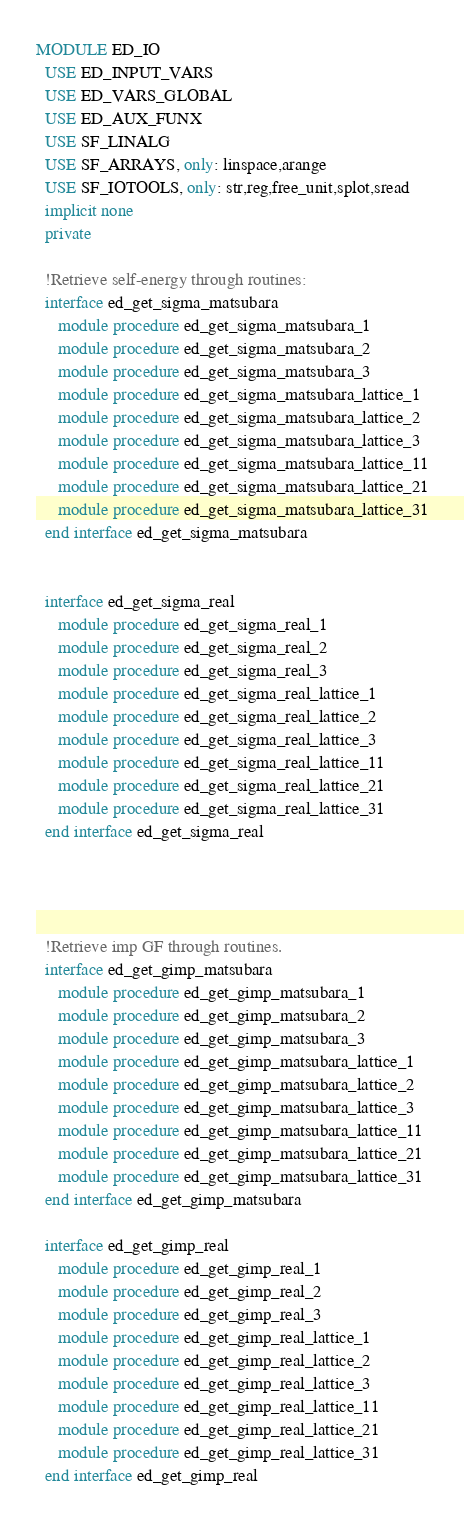<code> <loc_0><loc_0><loc_500><loc_500><_FORTRAN_>MODULE ED_IO
  USE ED_INPUT_VARS
  USE ED_VARS_GLOBAL
  USE ED_AUX_FUNX
  USE SF_LINALG
  USE SF_ARRAYS, only: linspace,arange
  USE SF_IOTOOLS, only: str,reg,free_unit,splot,sread
  implicit none
  private

  !Retrieve self-energy through routines:
  interface ed_get_sigma_matsubara
     module procedure ed_get_sigma_matsubara_1
     module procedure ed_get_sigma_matsubara_2
     module procedure ed_get_sigma_matsubara_3
     module procedure ed_get_sigma_matsubara_lattice_1
     module procedure ed_get_sigma_matsubara_lattice_2
     module procedure ed_get_sigma_matsubara_lattice_3
     module procedure ed_get_sigma_matsubara_lattice_11
     module procedure ed_get_sigma_matsubara_lattice_21
     module procedure ed_get_sigma_matsubara_lattice_31
  end interface ed_get_sigma_matsubara


  interface ed_get_sigma_real
     module procedure ed_get_sigma_real_1
     module procedure ed_get_sigma_real_2
     module procedure ed_get_sigma_real_3
     module procedure ed_get_sigma_real_lattice_1
     module procedure ed_get_sigma_real_lattice_2
     module procedure ed_get_sigma_real_lattice_3
     module procedure ed_get_sigma_real_lattice_11
     module procedure ed_get_sigma_real_lattice_21
     module procedure ed_get_sigma_real_lattice_31
  end interface ed_get_sigma_real




  !Retrieve imp GF through routines.
  interface ed_get_gimp_matsubara
     module procedure ed_get_gimp_matsubara_1
     module procedure ed_get_gimp_matsubara_2
     module procedure ed_get_gimp_matsubara_3
     module procedure ed_get_gimp_matsubara_lattice_1
     module procedure ed_get_gimp_matsubara_lattice_2
     module procedure ed_get_gimp_matsubara_lattice_3
     module procedure ed_get_gimp_matsubara_lattice_11
     module procedure ed_get_gimp_matsubara_lattice_21
     module procedure ed_get_gimp_matsubara_lattice_31
  end interface ed_get_gimp_matsubara

  interface ed_get_gimp_real
     module procedure ed_get_gimp_real_1
     module procedure ed_get_gimp_real_2
     module procedure ed_get_gimp_real_3
     module procedure ed_get_gimp_real_lattice_1
     module procedure ed_get_gimp_real_lattice_2
     module procedure ed_get_gimp_real_lattice_3
     module procedure ed_get_gimp_real_lattice_11
     module procedure ed_get_gimp_real_lattice_21
     module procedure ed_get_gimp_real_lattice_31
  end interface ed_get_gimp_real

</code> 